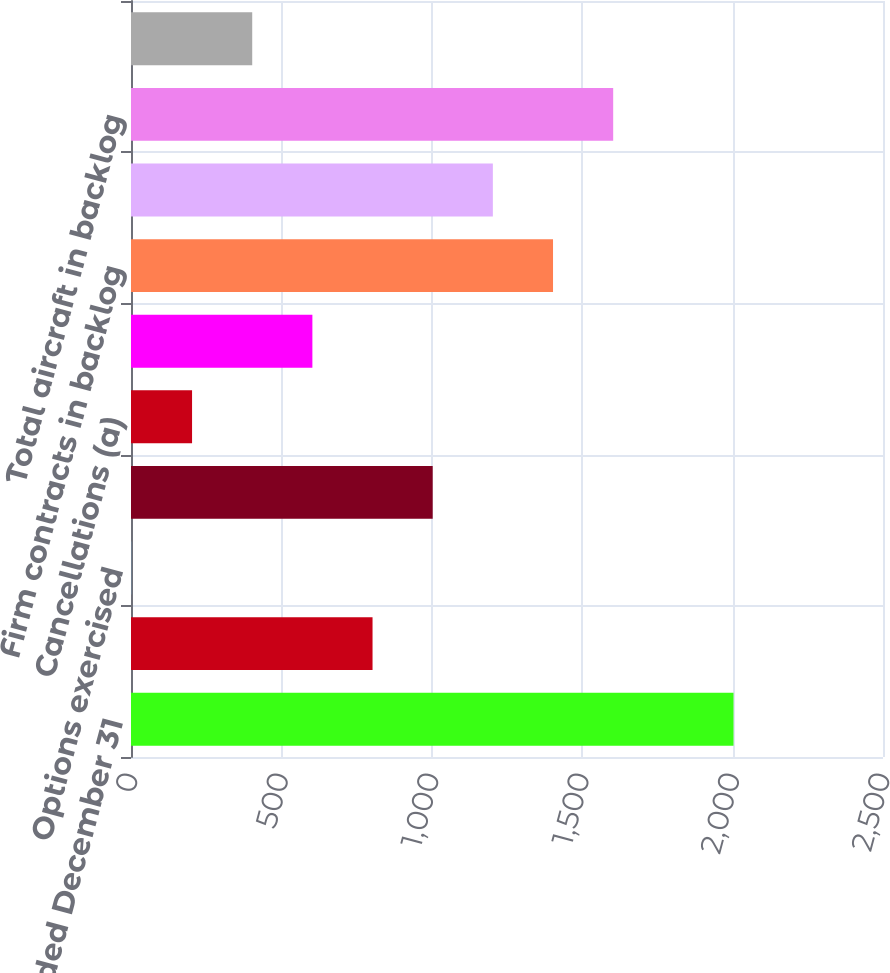<chart> <loc_0><loc_0><loc_500><loc_500><bar_chart><fcel>Year Ended December 31<fcel>New orders<fcel>Options exercised<fcel>Firm orders (a)<fcel>Cancellations (a)<fcel>Total orders<fcel>Firm contracts in backlog<fcel>Options in backlog<fcel>Total aircraft in backlog<fcel>Completions in backlog (b)<nl><fcel>2003<fcel>803<fcel>3<fcel>1003<fcel>203<fcel>603<fcel>1403<fcel>1203<fcel>1603<fcel>403<nl></chart> 